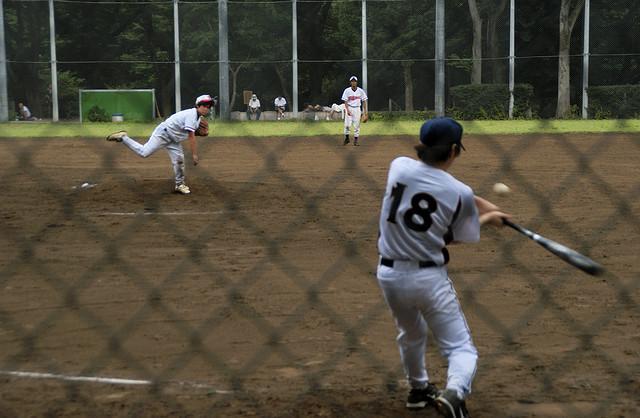Who will next cause the balls direction to change?
Select the accurate response from the four choices given to answer the question.
Options: 18, pitcher, coach, shortstop. 18. 